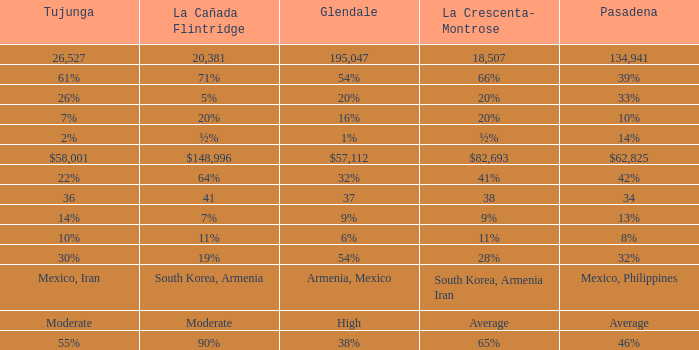What is the percentage of Glendale when Pasadena is 14%? 1%. 